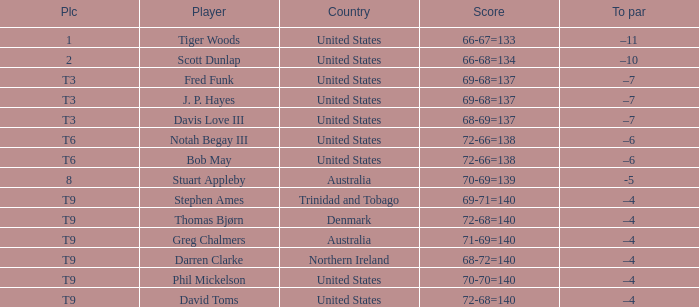What country is Stephen Ames from with a place value of t9? Trinidad and Tobago. 